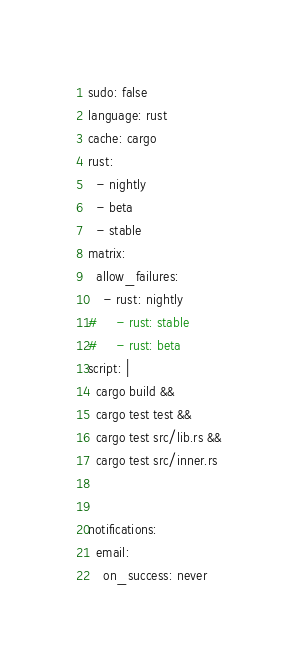Convert code to text. <code><loc_0><loc_0><loc_500><loc_500><_YAML_>sudo: false
language: rust
cache: cargo
rust:
  - nightly
  - beta
  - stable
matrix:
  allow_failures:
    - rust: nightly
#     - rust: stable
#     - rust: beta
script: |
  cargo build &&
  cargo test test &&
  cargo test src/lib.rs &&
  cargo test src/inner.rs
  

notifications:
  email:
    on_success: never</code> 